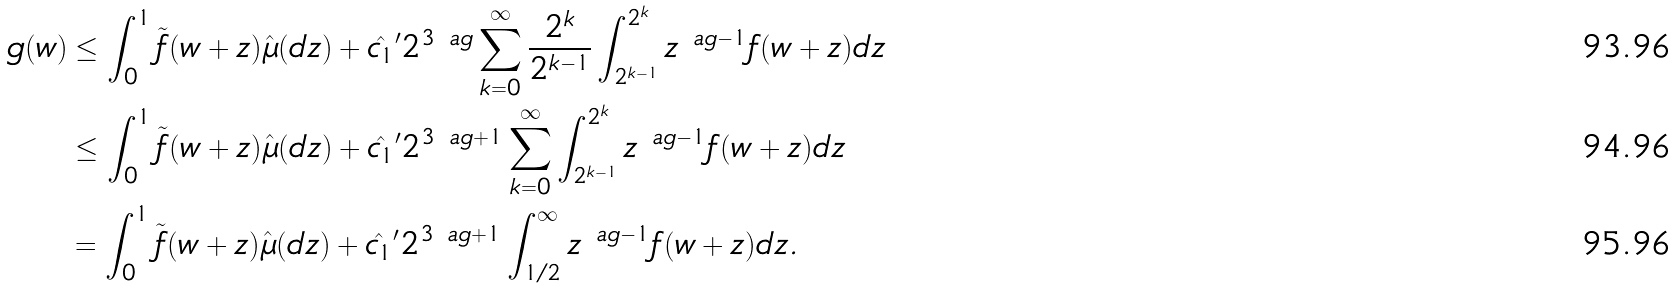<formula> <loc_0><loc_0><loc_500><loc_500>g ( w ) & \leq \int _ { 0 } ^ { 1 } \tilde { f } ( w + z ) \hat { \mu } ( d z ) + \hat { c _ { 1 } } ^ { \prime } 2 ^ { 3 \ a g } \sum _ { k = 0 } ^ { \infty } \frac { 2 ^ { k } } { 2 ^ { k - 1 } } \int _ { 2 ^ { k - 1 } } ^ { 2 ^ { k } } z ^ { \ a g - 1 } f ( w + z ) d z \\ & \leq \int _ { 0 } ^ { 1 } \tilde { f } ( w + z ) \hat { \mu } ( d z ) + \hat { c _ { 1 } } ^ { \prime } 2 ^ { 3 \ a g + 1 } \sum _ { k = 0 } ^ { \infty } \int _ { 2 ^ { k - 1 } } ^ { 2 ^ { k } } z ^ { \ a g - 1 } f ( w + z ) d z \\ & = \int _ { 0 } ^ { 1 } \tilde { f } ( w + z ) \hat { \mu } ( d z ) + \hat { c _ { 1 } } ^ { \prime } 2 ^ { 3 \ a g + 1 } \int _ { 1 / 2 } ^ { \infty } z ^ { \ a g - 1 } f ( w + z ) d z .</formula> 